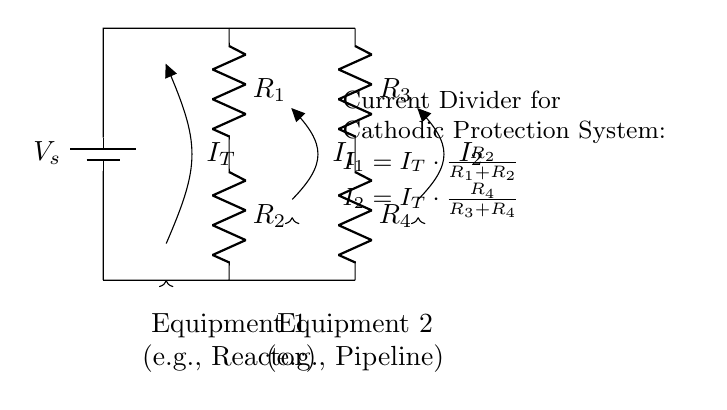What is the total current entering the circuit? The total current entering the circuit, denoted as I_T, is labeled in the diagram and represents the sum of the currents flowing through each of the resistors connected to the equipment.
Answer: I_T What are the resistances used in this current divider? The resistances in the current divider circuit are identified as R_1, R_2, R_3, and R_4, each contributing to how the current is divided between the two loads in the system.
Answer: R_1, R_2, R_3, R_4 What happens to the current when R_1 is increased? Increasing R_1 will decrease the current I_1, as per the current divider formula, which shows the relationship between resistance values and the divided currents.
Answer: I_1 decreases Which equipment utilizes current I_1? The diagram indicates that Equipment 1 (e.g., Reactor) utilizes the current I_1 as it is directly connected to this branch of the circuit.
Answer: Equipment 1 (e.g., Reactor) What is the formula for I_2 in this circuit? The formula for I_2 is given in the circuit diagram as I_2 = I_T * (R_4 / (R_3 + R_4)), which shows how I_2 is derived from the total current based on the resistances.
Answer: I_2 = I_T * (R_4 / (R_3 + R_4)) How does the current divider affect cathodic protection? The current divider assists in balancing the load between different equipment, ensuring that each piece receives adequate current for effective cathodic protection, which is crucial for preventing corrosion.
Answer: Balancing load for protection What type of circuit is depicted in this diagram? The circuit depicted is a current divider, specifically designed to divide total current among parallel paths in a cathodic protection system for enhanced efficiency in metal processing.
Answer: Current divider 